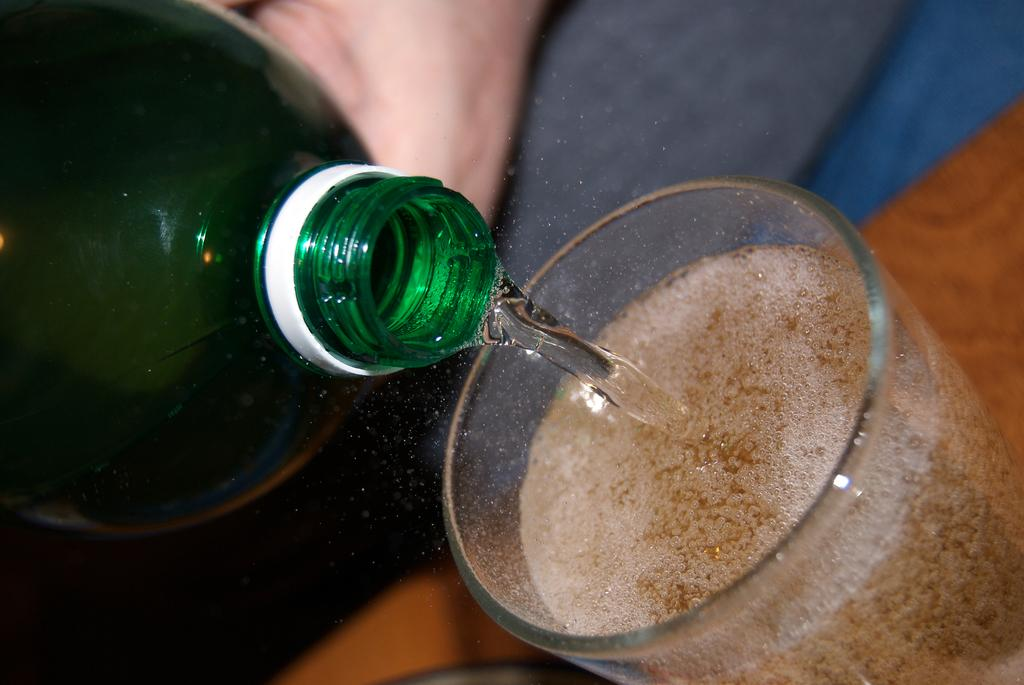What is on the table in the image? There is a glass on a table in the image. What is inside the glass? There is a drink in the glass. What else can be seen in the image? There is a bottle in the image. What is inside the bottle? There is water in the bottle. What type of meat is being cooked in the image? There is no meat or cooking activity present in the image. How does the doll interact with the rainstorm in the image? There is no doll or rainstorm present in the image. 